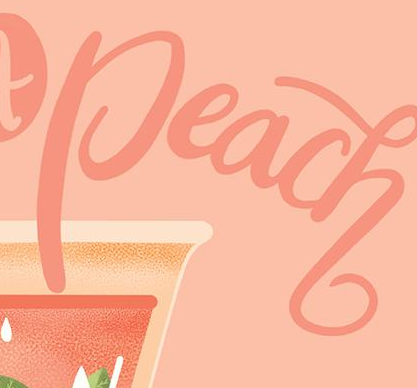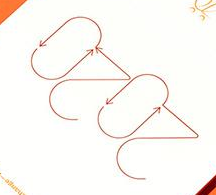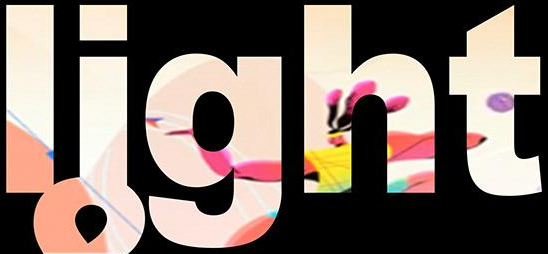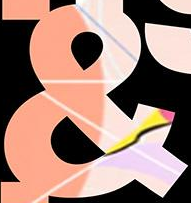Transcribe the words shown in these images in order, separated by a semicolon. Peach; 2020; light; & 